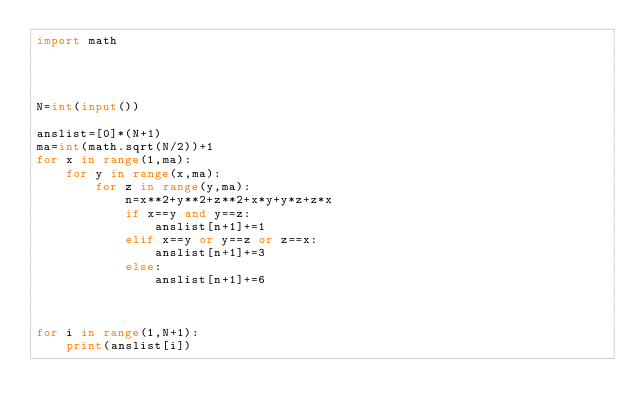<code> <loc_0><loc_0><loc_500><loc_500><_Python_>import math




N=int(input())

anslist=[0]*(N+1)
ma=int(math.sqrt(N/2))+1
for x in range(1,ma):
    for y in range(x,ma):
        for z in range(y,ma):
            n=x**2+y**2+z**2+x*y+y*z+z*x
            if x==y and y==z:
                anslist[n+1]+=1
            elif x==y or y==z or z==x:
                anslist[n+1]+=3
            else:
                anslist[n+1]+=6

            

for i in range(1,N+1):
    print(anslist[i])</code> 